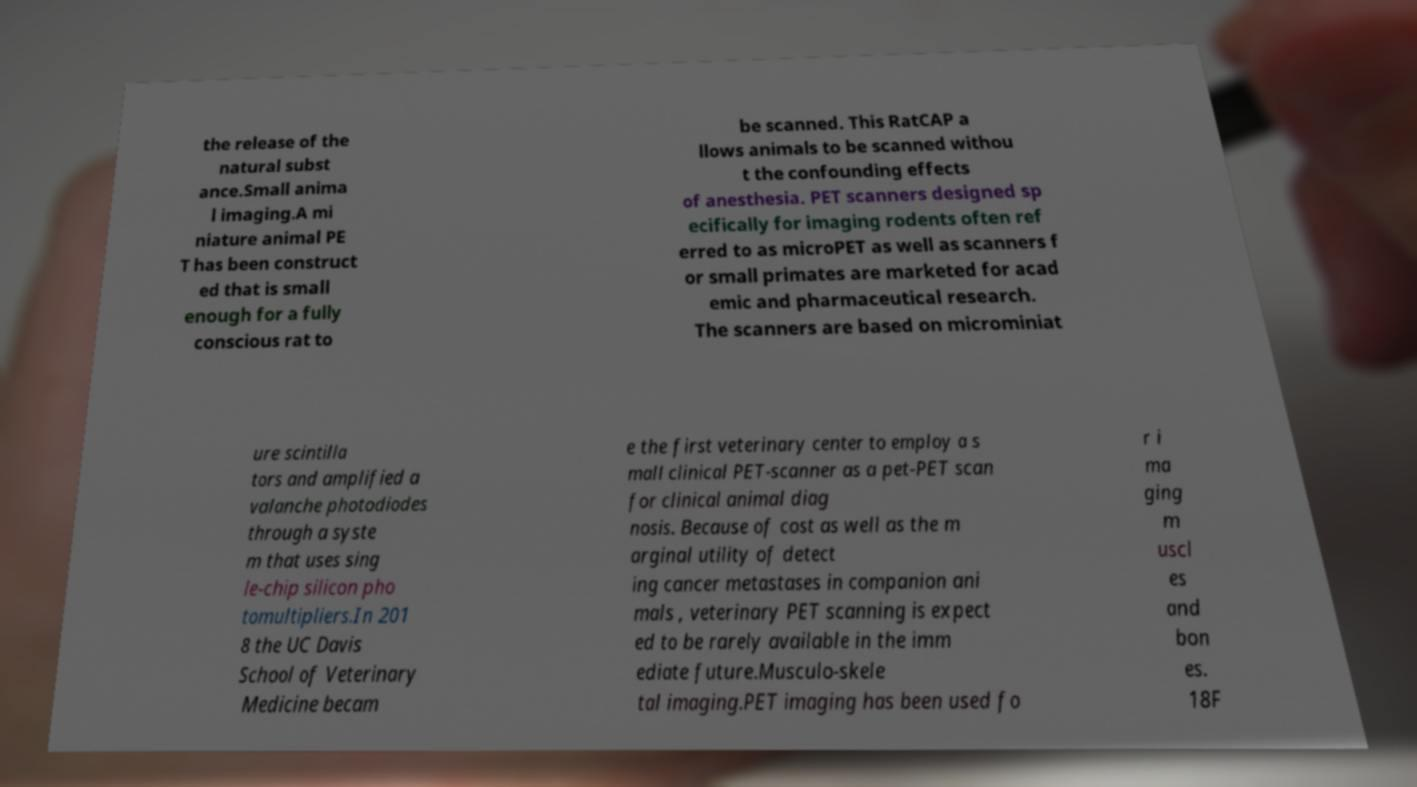Could you assist in decoding the text presented in this image and type it out clearly? the release of the natural subst ance.Small anima l imaging.A mi niature animal PE T has been construct ed that is small enough for a fully conscious rat to be scanned. This RatCAP a llows animals to be scanned withou t the confounding effects of anesthesia. PET scanners designed sp ecifically for imaging rodents often ref erred to as microPET as well as scanners f or small primates are marketed for acad emic and pharmaceutical research. The scanners are based on microminiat ure scintilla tors and amplified a valanche photodiodes through a syste m that uses sing le-chip silicon pho tomultipliers.In 201 8 the UC Davis School of Veterinary Medicine becam e the first veterinary center to employ a s mall clinical PET-scanner as a pet-PET scan for clinical animal diag nosis. Because of cost as well as the m arginal utility of detect ing cancer metastases in companion ani mals , veterinary PET scanning is expect ed to be rarely available in the imm ediate future.Musculo-skele tal imaging.PET imaging has been used fo r i ma ging m uscl es and bon es. 18F 